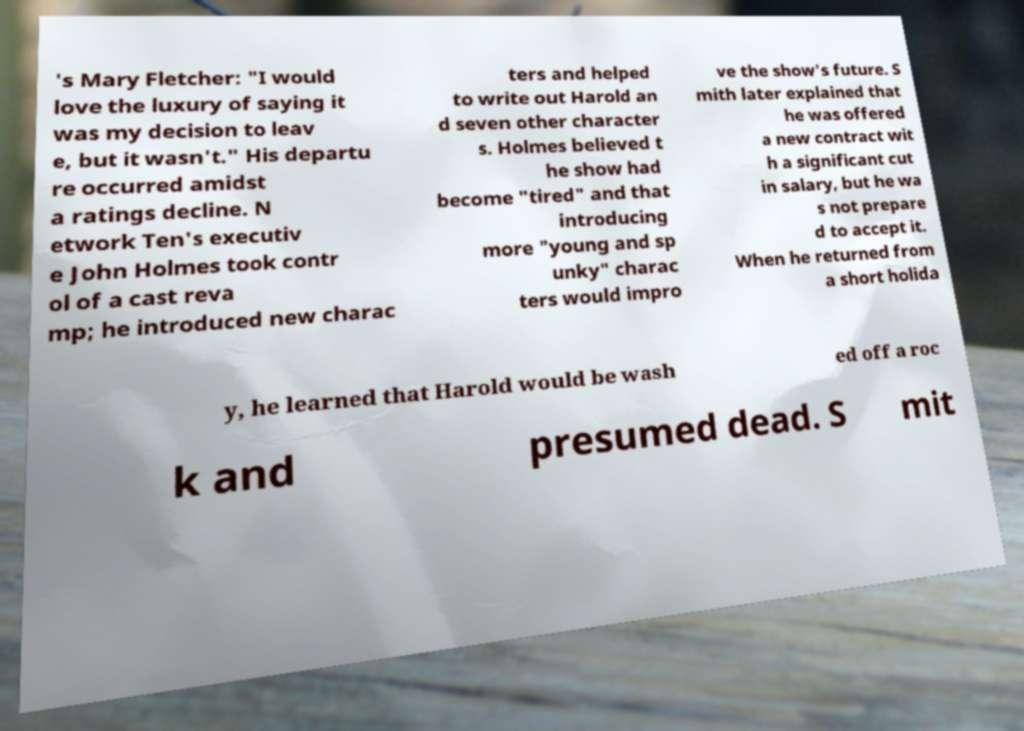For documentation purposes, I need the text within this image transcribed. Could you provide that? 's Mary Fletcher: "I would love the luxury of saying it was my decision to leav e, but it wasn't." His departu re occurred amidst a ratings decline. N etwork Ten's executiv e John Holmes took contr ol of a cast reva mp; he introduced new charac ters and helped to write out Harold an d seven other character s. Holmes believed t he show had become "tired" and that introducing more "young and sp unky" charac ters would impro ve the show's future. S mith later explained that he was offered a new contract wit h a significant cut in salary, but he wa s not prepare d to accept it. When he returned from a short holida y, he learned that Harold would be wash ed off a roc k and presumed dead. S mit 